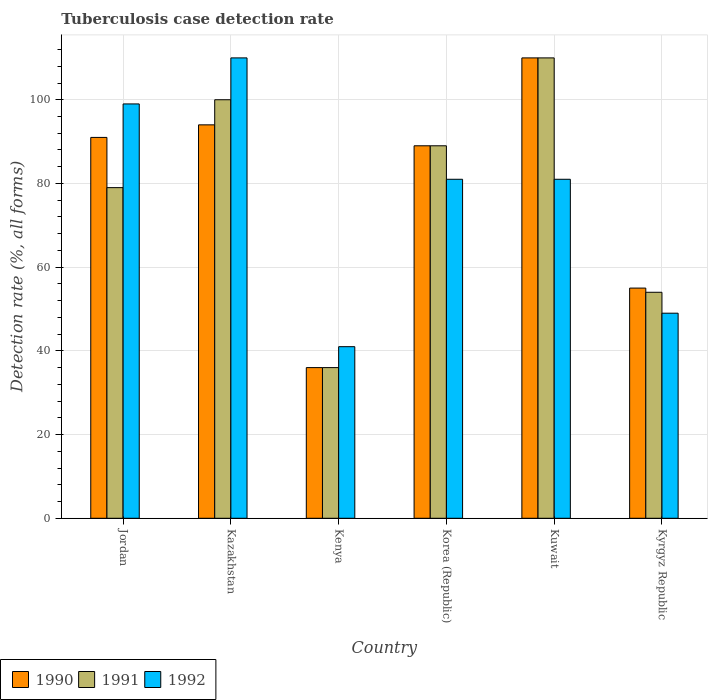How many groups of bars are there?
Give a very brief answer. 6. Are the number of bars per tick equal to the number of legend labels?
Your answer should be compact. Yes. How many bars are there on the 1st tick from the left?
Your response must be concise. 3. How many bars are there on the 1st tick from the right?
Provide a succinct answer. 3. What is the label of the 1st group of bars from the left?
Provide a short and direct response. Jordan. In how many cases, is the number of bars for a given country not equal to the number of legend labels?
Give a very brief answer. 0. What is the tuberculosis case detection rate in in 1990 in Korea (Republic)?
Your answer should be very brief. 89. Across all countries, what is the maximum tuberculosis case detection rate in in 1992?
Give a very brief answer. 110. Across all countries, what is the minimum tuberculosis case detection rate in in 1992?
Your answer should be very brief. 41. In which country was the tuberculosis case detection rate in in 1992 maximum?
Your answer should be compact. Kazakhstan. In which country was the tuberculosis case detection rate in in 1992 minimum?
Your answer should be compact. Kenya. What is the total tuberculosis case detection rate in in 1991 in the graph?
Offer a very short reply. 468. What is the difference between the tuberculosis case detection rate in in 1991 in Kenya and that in Korea (Republic)?
Give a very brief answer. -53. What is the difference between the tuberculosis case detection rate in in 1992 in Kyrgyz Republic and the tuberculosis case detection rate in in 1990 in Kazakhstan?
Provide a succinct answer. -45. What is the average tuberculosis case detection rate in in 1992 per country?
Give a very brief answer. 76.83. What is the difference between the tuberculosis case detection rate in of/in 1991 and tuberculosis case detection rate in of/in 1990 in Jordan?
Provide a succinct answer. -12. In how many countries, is the tuberculosis case detection rate in in 1991 greater than 104 %?
Provide a succinct answer. 1. What is the ratio of the tuberculosis case detection rate in in 1992 in Kazakhstan to that in Kyrgyz Republic?
Make the answer very short. 2.24. Is the tuberculosis case detection rate in in 1990 in Jordan less than that in Kuwait?
Your answer should be compact. Yes. What is the difference between the highest and the second highest tuberculosis case detection rate in in 1992?
Give a very brief answer. -18. What is the difference between the highest and the lowest tuberculosis case detection rate in in 1992?
Your response must be concise. 69. In how many countries, is the tuberculosis case detection rate in in 1991 greater than the average tuberculosis case detection rate in in 1991 taken over all countries?
Your answer should be compact. 4. What does the 3rd bar from the left in Kenya represents?
Provide a short and direct response. 1992. What does the 1st bar from the right in Kenya represents?
Provide a short and direct response. 1992. Is it the case that in every country, the sum of the tuberculosis case detection rate in in 1991 and tuberculosis case detection rate in in 1990 is greater than the tuberculosis case detection rate in in 1992?
Your answer should be compact. Yes. How many bars are there?
Provide a succinct answer. 18. What is the difference between two consecutive major ticks on the Y-axis?
Offer a terse response. 20. Does the graph contain grids?
Offer a terse response. Yes. Where does the legend appear in the graph?
Give a very brief answer. Bottom left. How many legend labels are there?
Offer a terse response. 3. What is the title of the graph?
Your answer should be compact. Tuberculosis case detection rate. What is the label or title of the X-axis?
Keep it short and to the point. Country. What is the label or title of the Y-axis?
Provide a short and direct response. Detection rate (%, all forms). What is the Detection rate (%, all forms) in 1990 in Jordan?
Give a very brief answer. 91. What is the Detection rate (%, all forms) in 1991 in Jordan?
Offer a terse response. 79. What is the Detection rate (%, all forms) of 1992 in Jordan?
Give a very brief answer. 99. What is the Detection rate (%, all forms) of 1990 in Kazakhstan?
Offer a terse response. 94. What is the Detection rate (%, all forms) of 1991 in Kazakhstan?
Provide a succinct answer. 100. What is the Detection rate (%, all forms) of 1992 in Kazakhstan?
Your response must be concise. 110. What is the Detection rate (%, all forms) in 1990 in Kenya?
Provide a short and direct response. 36. What is the Detection rate (%, all forms) of 1992 in Kenya?
Offer a very short reply. 41. What is the Detection rate (%, all forms) in 1990 in Korea (Republic)?
Ensure brevity in your answer.  89. What is the Detection rate (%, all forms) in 1991 in Korea (Republic)?
Provide a short and direct response. 89. What is the Detection rate (%, all forms) in 1990 in Kuwait?
Ensure brevity in your answer.  110. What is the Detection rate (%, all forms) of 1991 in Kuwait?
Offer a very short reply. 110. What is the Detection rate (%, all forms) in 1992 in Kuwait?
Keep it short and to the point. 81. What is the Detection rate (%, all forms) of 1991 in Kyrgyz Republic?
Offer a very short reply. 54. Across all countries, what is the maximum Detection rate (%, all forms) of 1990?
Provide a succinct answer. 110. Across all countries, what is the maximum Detection rate (%, all forms) in 1991?
Your response must be concise. 110. Across all countries, what is the maximum Detection rate (%, all forms) in 1992?
Make the answer very short. 110. Across all countries, what is the minimum Detection rate (%, all forms) of 1990?
Offer a very short reply. 36. Across all countries, what is the minimum Detection rate (%, all forms) of 1992?
Offer a terse response. 41. What is the total Detection rate (%, all forms) in 1990 in the graph?
Give a very brief answer. 475. What is the total Detection rate (%, all forms) of 1991 in the graph?
Ensure brevity in your answer.  468. What is the total Detection rate (%, all forms) of 1992 in the graph?
Offer a terse response. 461. What is the difference between the Detection rate (%, all forms) of 1990 in Jordan and that in Kazakhstan?
Your answer should be compact. -3. What is the difference between the Detection rate (%, all forms) in 1992 in Jordan and that in Kenya?
Ensure brevity in your answer.  58. What is the difference between the Detection rate (%, all forms) of 1990 in Jordan and that in Korea (Republic)?
Your response must be concise. 2. What is the difference between the Detection rate (%, all forms) in 1991 in Jordan and that in Kuwait?
Provide a short and direct response. -31. What is the difference between the Detection rate (%, all forms) of 1992 in Jordan and that in Kuwait?
Keep it short and to the point. 18. What is the difference between the Detection rate (%, all forms) of 1991 in Jordan and that in Kyrgyz Republic?
Offer a terse response. 25. What is the difference between the Detection rate (%, all forms) in 1992 in Jordan and that in Kyrgyz Republic?
Provide a short and direct response. 50. What is the difference between the Detection rate (%, all forms) in 1991 in Kazakhstan and that in Kenya?
Offer a very short reply. 64. What is the difference between the Detection rate (%, all forms) in 1990 in Kazakhstan and that in Korea (Republic)?
Provide a short and direct response. 5. What is the difference between the Detection rate (%, all forms) in 1991 in Kazakhstan and that in Korea (Republic)?
Provide a succinct answer. 11. What is the difference between the Detection rate (%, all forms) in 1992 in Kazakhstan and that in Kyrgyz Republic?
Offer a terse response. 61. What is the difference between the Detection rate (%, all forms) of 1990 in Kenya and that in Korea (Republic)?
Give a very brief answer. -53. What is the difference between the Detection rate (%, all forms) of 1991 in Kenya and that in Korea (Republic)?
Your answer should be very brief. -53. What is the difference between the Detection rate (%, all forms) in 1992 in Kenya and that in Korea (Republic)?
Your answer should be very brief. -40. What is the difference between the Detection rate (%, all forms) in 1990 in Kenya and that in Kuwait?
Give a very brief answer. -74. What is the difference between the Detection rate (%, all forms) in 1991 in Kenya and that in Kuwait?
Your response must be concise. -74. What is the difference between the Detection rate (%, all forms) in 1991 in Kenya and that in Kyrgyz Republic?
Give a very brief answer. -18. What is the difference between the Detection rate (%, all forms) in 1992 in Kenya and that in Kyrgyz Republic?
Make the answer very short. -8. What is the difference between the Detection rate (%, all forms) of 1990 in Korea (Republic) and that in Kuwait?
Your answer should be compact. -21. What is the difference between the Detection rate (%, all forms) in 1991 in Korea (Republic) and that in Kuwait?
Offer a terse response. -21. What is the difference between the Detection rate (%, all forms) in 1992 in Korea (Republic) and that in Kuwait?
Offer a very short reply. 0. What is the difference between the Detection rate (%, all forms) in 1990 in Korea (Republic) and that in Kyrgyz Republic?
Provide a succinct answer. 34. What is the difference between the Detection rate (%, all forms) of 1990 in Kuwait and that in Kyrgyz Republic?
Keep it short and to the point. 55. What is the difference between the Detection rate (%, all forms) in 1991 in Kuwait and that in Kyrgyz Republic?
Provide a succinct answer. 56. What is the difference between the Detection rate (%, all forms) in 1990 in Jordan and the Detection rate (%, all forms) in 1991 in Kazakhstan?
Your answer should be very brief. -9. What is the difference between the Detection rate (%, all forms) in 1991 in Jordan and the Detection rate (%, all forms) in 1992 in Kazakhstan?
Give a very brief answer. -31. What is the difference between the Detection rate (%, all forms) of 1990 in Jordan and the Detection rate (%, all forms) of 1991 in Kenya?
Offer a very short reply. 55. What is the difference between the Detection rate (%, all forms) in 1990 in Jordan and the Detection rate (%, all forms) in 1991 in Korea (Republic)?
Your response must be concise. 2. What is the difference between the Detection rate (%, all forms) of 1991 in Jordan and the Detection rate (%, all forms) of 1992 in Korea (Republic)?
Keep it short and to the point. -2. What is the difference between the Detection rate (%, all forms) of 1990 in Jordan and the Detection rate (%, all forms) of 1991 in Kuwait?
Provide a short and direct response. -19. What is the difference between the Detection rate (%, all forms) in 1991 in Jordan and the Detection rate (%, all forms) in 1992 in Kyrgyz Republic?
Ensure brevity in your answer.  30. What is the difference between the Detection rate (%, all forms) in 1990 in Kazakhstan and the Detection rate (%, all forms) in 1991 in Kenya?
Offer a very short reply. 58. What is the difference between the Detection rate (%, all forms) of 1990 in Kazakhstan and the Detection rate (%, all forms) of 1992 in Kenya?
Your answer should be compact. 53. What is the difference between the Detection rate (%, all forms) of 1991 in Kazakhstan and the Detection rate (%, all forms) of 1992 in Kenya?
Provide a succinct answer. 59. What is the difference between the Detection rate (%, all forms) of 1990 in Kazakhstan and the Detection rate (%, all forms) of 1991 in Korea (Republic)?
Keep it short and to the point. 5. What is the difference between the Detection rate (%, all forms) in 1990 in Kazakhstan and the Detection rate (%, all forms) in 1991 in Kuwait?
Provide a short and direct response. -16. What is the difference between the Detection rate (%, all forms) in 1990 in Kazakhstan and the Detection rate (%, all forms) in 1992 in Kuwait?
Offer a very short reply. 13. What is the difference between the Detection rate (%, all forms) of 1991 in Kazakhstan and the Detection rate (%, all forms) of 1992 in Kuwait?
Your answer should be compact. 19. What is the difference between the Detection rate (%, all forms) in 1990 in Kazakhstan and the Detection rate (%, all forms) in 1991 in Kyrgyz Republic?
Keep it short and to the point. 40. What is the difference between the Detection rate (%, all forms) of 1990 in Kazakhstan and the Detection rate (%, all forms) of 1992 in Kyrgyz Republic?
Your answer should be very brief. 45. What is the difference between the Detection rate (%, all forms) of 1990 in Kenya and the Detection rate (%, all forms) of 1991 in Korea (Republic)?
Provide a short and direct response. -53. What is the difference between the Detection rate (%, all forms) in 1990 in Kenya and the Detection rate (%, all forms) in 1992 in Korea (Republic)?
Provide a succinct answer. -45. What is the difference between the Detection rate (%, all forms) of 1991 in Kenya and the Detection rate (%, all forms) of 1992 in Korea (Republic)?
Provide a succinct answer. -45. What is the difference between the Detection rate (%, all forms) of 1990 in Kenya and the Detection rate (%, all forms) of 1991 in Kuwait?
Offer a very short reply. -74. What is the difference between the Detection rate (%, all forms) of 1990 in Kenya and the Detection rate (%, all forms) of 1992 in Kuwait?
Offer a terse response. -45. What is the difference between the Detection rate (%, all forms) of 1991 in Kenya and the Detection rate (%, all forms) of 1992 in Kuwait?
Provide a succinct answer. -45. What is the difference between the Detection rate (%, all forms) of 1991 in Kenya and the Detection rate (%, all forms) of 1992 in Kyrgyz Republic?
Ensure brevity in your answer.  -13. What is the difference between the Detection rate (%, all forms) in 1990 in Korea (Republic) and the Detection rate (%, all forms) in 1992 in Kuwait?
Offer a very short reply. 8. What is the difference between the Detection rate (%, all forms) in 1991 in Korea (Republic) and the Detection rate (%, all forms) in 1992 in Kyrgyz Republic?
Make the answer very short. 40. What is the difference between the Detection rate (%, all forms) of 1990 in Kuwait and the Detection rate (%, all forms) of 1992 in Kyrgyz Republic?
Offer a terse response. 61. What is the average Detection rate (%, all forms) of 1990 per country?
Keep it short and to the point. 79.17. What is the average Detection rate (%, all forms) in 1992 per country?
Provide a succinct answer. 76.83. What is the difference between the Detection rate (%, all forms) in 1990 and Detection rate (%, all forms) in 1992 in Jordan?
Offer a very short reply. -8. What is the difference between the Detection rate (%, all forms) in 1990 and Detection rate (%, all forms) in 1991 in Kazakhstan?
Your answer should be very brief. -6. What is the difference between the Detection rate (%, all forms) of 1990 and Detection rate (%, all forms) of 1992 in Kazakhstan?
Provide a succinct answer. -16. What is the difference between the Detection rate (%, all forms) in 1990 and Detection rate (%, all forms) in 1991 in Kenya?
Keep it short and to the point. 0. What is the difference between the Detection rate (%, all forms) of 1990 and Detection rate (%, all forms) of 1992 in Kenya?
Give a very brief answer. -5. What is the difference between the Detection rate (%, all forms) of 1991 and Detection rate (%, all forms) of 1992 in Kenya?
Provide a short and direct response. -5. What is the difference between the Detection rate (%, all forms) in 1991 and Detection rate (%, all forms) in 1992 in Korea (Republic)?
Provide a short and direct response. 8. What is the difference between the Detection rate (%, all forms) of 1990 and Detection rate (%, all forms) of 1991 in Kyrgyz Republic?
Your response must be concise. 1. What is the difference between the Detection rate (%, all forms) of 1990 and Detection rate (%, all forms) of 1992 in Kyrgyz Republic?
Give a very brief answer. 6. What is the difference between the Detection rate (%, all forms) of 1991 and Detection rate (%, all forms) of 1992 in Kyrgyz Republic?
Offer a very short reply. 5. What is the ratio of the Detection rate (%, all forms) in 1990 in Jordan to that in Kazakhstan?
Provide a short and direct response. 0.97. What is the ratio of the Detection rate (%, all forms) in 1991 in Jordan to that in Kazakhstan?
Keep it short and to the point. 0.79. What is the ratio of the Detection rate (%, all forms) of 1992 in Jordan to that in Kazakhstan?
Give a very brief answer. 0.9. What is the ratio of the Detection rate (%, all forms) in 1990 in Jordan to that in Kenya?
Your answer should be very brief. 2.53. What is the ratio of the Detection rate (%, all forms) in 1991 in Jordan to that in Kenya?
Make the answer very short. 2.19. What is the ratio of the Detection rate (%, all forms) of 1992 in Jordan to that in Kenya?
Your response must be concise. 2.41. What is the ratio of the Detection rate (%, all forms) in 1990 in Jordan to that in Korea (Republic)?
Give a very brief answer. 1.02. What is the ratio of the Detection rate (%, all forms) of 1991 in Jordan to that in Korea (Republic)?
Your answer should be compact. 0.89. What is the ratio of the Detection rate (%, all forms) of 1992 in Jordan to that in Korea (Republic)?
Give a very brief answer. 1.22. What is the ratio of the Detection rate (%, all forms) in 1990 in Jordan to that in Kuwait?
Provide a succinct answer. 0.83. What is the ratio of the Detection rate (%, all forms) in 1991 in Jordan to that in Kuwait?
Keep it short and to the point. 0.72. What is the ratio of the Detection rate (%, all forms) of 1992 in Jordan to that in Kuwait?
Keep it short and to the point. 1.22. What is the ratio of the Detection rate (%, all forms) of 1990 in Jordan to that in Kyrgyz Republic?
Provide a succinct answer. 1.65. What is the ratio of the Detection rate (%, all forms) in 1991 in Jordan to that in Kyrgyz Republic?
Keep it short and to the point. 1.46. What is the ratio of the Detection rate (%, all forms) of 1992 in Jordan to that in Kyrgyz Republic?
Provide a short and direct response. 2.02. What is the ratio of the Detection rate (%, all forms) of 1990 in Kazakhstan to that in Kenya?
Give a very brief answer. 2.61. What is the ratio of the Detection rate (%, all forms) of 1991 in Kazakhstan to that in Kenya?
Ensure brevity in your answer.  2.78. What is the ratio of the Detection rate (%, all forms) in 1992 in Kazakhstan to that in Kenya?
Your answer should be very brief. 2.68. What is the ratio of the Detection rate (%, all forms) in 1990 in Kazakhstan to that in Korea (Republic)?
Ensure brevity in your answer.  1.06. What is the ratio of the Detection rate (%, all forms) of 1991 in Kazakhstan to that in Korea (Republic)?
Offer a terse response. 1.12. What is the ratio of the Detection rate (%, all forms) in 1992 in Kazakhstan to that in Korea (Republic)?
Your answer should be compact. 1.36. What is the ratio of the Detection rate (%, all forms) in 1990 in Kazakhstan to that in Kuwait?
Give a very brief answer. 0.85. What is the ratio of the Detection rate (%, all forms) of 1992 in Kazakhstan to that in Kuwait?
Keep it short and to the point. 1.36. What is the ratio of the Detection rate (%, all forms) in 1990 in Kazakhstan to that in Kyrgyz Republic?
Make the answer very short. 1.71. What is the ratio of the Detection rate (%, all forms) in 1991 in Kazakhstan to that in Kyrgyz Republic?
Your answer should be very brief. 1.85. What is the ratio of the Detection rate (%, all forms) in 1992 in Kazakhstan to that in Kyrgyz Republic?
Keep it short and to the point. 2.24. What is the ratio of the Detection rate (%, all forms) in 1990 in Kenya to that in Korea (Republic)?
Your response must be concise. 0.4. What is the ratio of the Detection rate (%, all forms) of 1991 in Kenya to that in Korea (Republic)?
Offer a terse response. 0.4. What is the ratio of the Detection rate (%, all forms) of 1992 in Kenya to that in Korea (Republic)?
Your response must be concise. 0.51. What is the ratio of the Detection rate (%, all forms) in 1990 in Kenya to that in Kuwait?
Your answer should be very brief. 0.33. What is the ratio of the Detection rate (%, all forms) of 1991 in Kenya to that in Kuwait?
Keep it short and to the point. 0.33. What is the ratio of the Detection rate (%, all forms) in 1992 in Kenya to that in Kuwait?
Your answer should be very brief. 0.51. What is the ratio of the Detection rate (%, all forms) of 1990 in Kenya to that in Kyrgyz Republic?
Keep it short and to the point. 0.65. What is the ratio of the Detection rate (%, all forms) in 1991 in Kenya to that in Kyrgyz Republic?
Make the answer very short. 0.67. What is the ratio of the Detection rate (%, all forms) of 1992 in Kenya to that in Kyrgyz Republic?
Your response must be concise. 0.84. What is the ratio of the Detection rate (%, all forms) of 1990 in Korea (Republic) to that in Kuwait?
Give a very brief answer. 0.81. What is the ratio of the Detection rate (%, all forms) in 1991 in Korea (Republic) to that in Kuwait?
Provide a succinct answer. 0.81. What is the ratio of the Detection rate (%, all forms) in 1992 in Korea (Republic) to that in Kuwait?
Provide a succinct answer. 1. What is the ratio of the Detection rate (%, all forms) in 1990 in Korea (Republic) to that in Kyrgyz Republic?
Provide a short and direct response. 1.62. What is the ratio of the Detection rate (%, all forms) of 1991 in Korea (Republic) to that in Kyrgyz Republic?
Offer a terse response. 1.65. What is the ratio of the Detection rate (%, all forms) in 1992 in Korea (Republic) to that in Kyrgyz Republic?
Provide a short and direct response. 1.65. What is the ratio of the Detection rate (%, all forms) of 1990 in Kuwait to that in Kyrgyz Republic?
Give a very brief answer. 2. What is the ratio of the Detection rate (%, all forms) in 1991 in Kuwait to that in Kyrgyz Republic?
Your answer should be very brief. 2.04. What is the ratio of the Detection rate (%, all forms) in 1992 in Kuwait to that in Kyrgyz Republic?
Provide a succinct answer. 1.65. What is the difference between the highest and the lowest Detection rate (%, all forms) in 1990?
Ensure brevity in your answer.  74. What is the difference between the highest and the lowest Detection rate (%, all forms) in 1992?
Your answer should be compact. 69. 